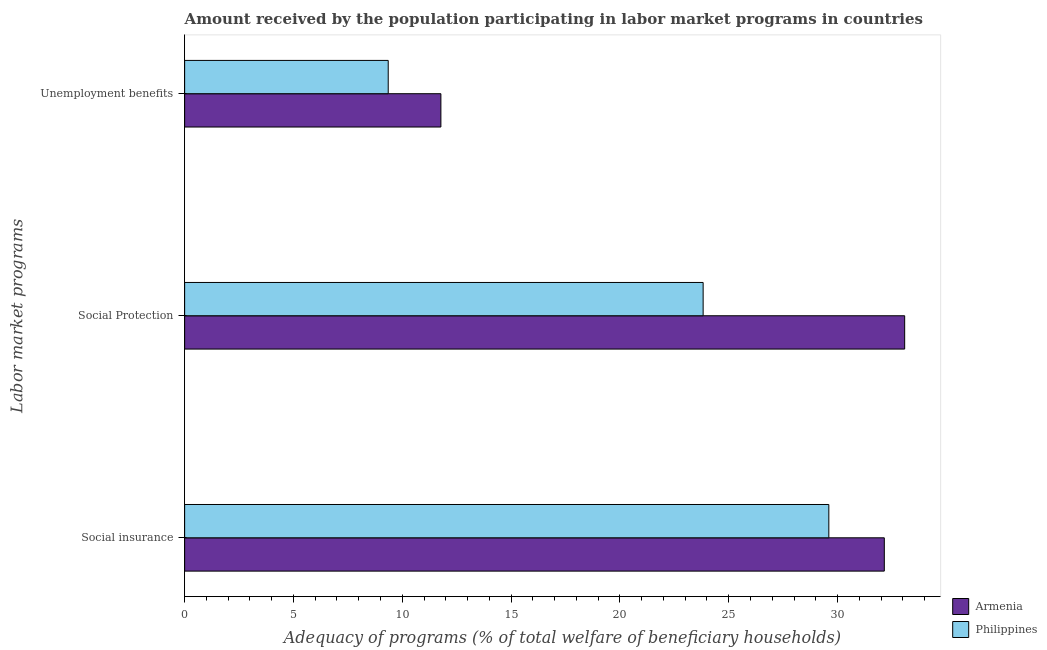Are the number of bars on each tick of the Y-axis equal?
Offer a very short reply. Yes. How many bars are there on the 3rd tick from the bottom?
Make the answer very short. 2. What is the label of the 2nd group of bars from the top?
Provide a short and direct response. Social Protection. What is the amount received by the population participating in social insurance programs in Philippines?
Ensure brevity in your answer.  29.6. Across all countries, what is the maximum amount received by the population participating in unemployment benefits programs?
Offer a terse response. 11.77. Across all countries, what is the minimum amount received by the population participating in unemployment benefits programs?
Ensure brevity in your answer.  9.35. In which country was the amount received by the population participating in social insurance programs maximum?
Your answer should be very brief. Armenia. In which country was the amount received by the population participating in social protection programs minimum?
Offer a terse response. Philippines. What is the total amount received by the population participating in unemployment benefits programs in the graph?
Your answer should be compact. 21.13. What is the difference between the amount received by the population participating in social protection programs in Philippines and that in Armenia?
Offer a terse response. -9.26. What is the difference between the amount received by the population participating in unemployment benefits programs in Armenia and the amount received by the population participating in social insurance programs in Philippines?
Offer a terse response. -17.83. What is the average amount received by the population participating in unemployment benefits programs per country?
Your response must be concise. 10.56. What is the difference between the amount received by the population participating in social insurance programs and amount received by the population participating in social protection programs in Philippines?
Keep it short and to the point. 5.78. In how many countries, is the amount received by the population participating in social protection programs greater than 23 %?
Give a very brief answer. 2. What is the ratio of the amount received by the population participating in unemployment benefits programs in Philippines to that in Armenia?
Keep it short and to the point. 0.79. Is the amount received by the population participating in social protection programs in Armenia less than that in Philippines?
Offer a terse response. No. Is the difference between the amount received by the population participating in social insurance programs in Philippines and Armenia greater than the difference between the amount received by the population participating in social protection programs in Philippines and Armenia?
Provide a succinct answer. Yes. What is the difference between the highest and the second highest amount received by the population participating in social protection programs?
Your answer should be very brief. 9.26. What is the difference between the highest and the lowest amount received by the population participating in unemployment benefits programs?
Your response must be concise. 2.42. In how many countries, is the amount received by the population participating in unemployment benefits programs greater than the average amount received by the population participating in unemployment benefits programs taken over all countries?
Your response must be concise. 1. Is the sum of the amount received by the population participating in unemployment benefits programs in Philippines and Armenia greater than the maximum amount received by the population participating in social protection programs across all countries?
Provide a short and direct response. No. What does the 2nd bar from the top in Unemployment benefits represents?
Your answer should be very brief. Armenia. Is it the case that in every country, the sum of the amount received by the population participating in social insurance programs and amount received by the population participating in social protection programs is greater than the amount received by the population participating in unemployment benefits programs?
Keep it short and to the point. Yes. How many bars are there?
Give a very brief answer. 6. Are the values on the major ticks of X-axis written in scientific E-notation?
Offer a terse response. No. Does the graph contain any zero values?
Offer a terse response. No. Does the graph contain grids?
Your answer should be very brief. No. How many legend labels are there?
Ensure brevity in your answer.  2. How are the legend labels stacked?
Offer a very short reply. Vertical. What is the title of the graph?
Offer a very short reply. Amount received by the population participating in labor market programs in countries. What is the label or title of the X-axis?
Provide a succinct answer. Adequacy of programs (% of total welfare of beneficiary households). What is the label or title of the Y-axis?
Ensure brevity in your answer.  Labor market programs. What is the Adequacy of programs (% of total welfare of beneficiary households) of Armenia in Social insurance?
Your answer should be very brief. 32.15. What is the Adequacy of programs (% of total welfare of beneficiary households) in Philippines in Social insurance?
Your answer should be very brief. 29.6. What is the Adequacy of programs (% of total welfare of beneficiary households) of Armenia in Social Protection?
Give a very brief answer. 33.08. What is the Adequacy of programs (% of total welfare of beneficiary households) in Philippines in Social Protection?
Keep it short and to the point. 23.82. What is the Adequacy of programs (% of total welfare of beneficiary households) in Armenia in Unemployment benefits?
Your answer should be compact. 11.77. What is the Adequacy of programs (% of total welfare of beneficiary households) in Philippines in Unemployment benefits?
Give a very brief answer. 9.35. Across all Labor market programs, what is the maximum Adequacy of programs (% of total welfare of beneficiary households) in Armenia?
Ensure brevity in your answer.  33.08. Across all Labor market programs, what is the maximum Adequacy of programs (% of total welfare of beneficiary households) in Philippines?
Your answer should be very brief. 29.6. Across all Labor market programs, what is the minimum Adequacy of programs (% of total welfare of beneficiary households) of Armenia?
Keep it short and to the point. 11.77. Across all Labor market programs, what is the minimum Adequacy of programs (% of total welfare of beneficiary households) of Philippines?
Give a very brief answer. 9.35. What is the total Adequacy of programs (% of total welfare of beneficiary households) in Armenia in the graph?
Your answer should be very brief. 77.01. What is the total Adequacy of programs (% of total welfare of beneficiary households) in Philippines in the graph?
Your response must be concise. 62.78. What is the difference between the Adequacy of programs (% of total welfare of beneficiary households) in Armenia in Social insurance and that in Social Protection?
Provide a short and direct response. -0.94. What is the difference between the Adequacy of programs (% of total welfare of beneficiary households) of Philippines in Social insurance and that in Social Protection?
Make the answer very short. 5.78. What is the difference between the Adequacy of programs (% of total welfare of beneficiary households) of Armenia in Social insurance and that in Unemployment benefits?
Your answer should be very brief. 20.37. What is the difference between the Adequacy of programs (% of total welfare of beneficiary households) in Philippines in Social insurance and that in Unemployment benefits?
Provide a short and direct response. 20.25. What is the difference between the Adequacy of programs (% of total welfare of beneficiary households) in Armenia in Social Protection and that in Unemployment benefits?
Your response must be concise. 21.31. What is the difference between the Adequacy of programs (% of total welfare of beneficiary households) in Philippines in Social Protection and that in Unemployment benefits?
Make the answer very short. 14.47. What is the difference between the Adequacy of programs (% of total welfare of beneficiary households) in Armenia in Social insurance and the Adequacy of programs (% of total welfare of beneficiary households) in Philippines in Social Protection?
Offer a terse response. 8.32. What is the difference between the Adequacy of programs (% of total welfare of beneficiary households) in Armenia in Social insurance and the Adequacy of programs (% of total welfare of beneficiary households) in Philippines in Unemployment benefits?
Make the answer very short. 22.79. What is the difference between the Adequacy of programs (% of total welfare of beneficiary households) of Armenia in Social Protection and the Adequacy of programs (% of total welfare of beneficiary households) of Philippines in Unemployment benefits?
Give a very brief answer. 23.73. What is the average Adequacy of programs (% of total welfare of beneficiary households) in Armenia per Labor market programs?
Your answer should be very brief. 25.67. What is the average Adequacy of programs (% of total welfare of beneficiary households) in Philippines per Labor market programs?
Give a very brief answer. 20.93. What is the difference between the Adequacy of programs (% of total welfare of beneficiary households) in Armenia and Adequacy of programs (% of total welfare of beneficiary households) in Philippines in Social insurance?
Give a very brief answer. 2.55. What is the difference between the Adequacy of programs (% of total welfare of beneficiary households) in Armenia and Adequacy of programs (% of total welfare of beneficiary households) in Philippines in Social Protection?
Keep it short and to the point. 9.26. What is the difference between the Adequacy of programs (% of total welfare of beneficiary households) of Armenia and Adequacy of programs (% of total welfare of beneficiary households) of Philippines in Unemployment benefits?
Your answer should be very brief. 2.42. What is the ratio of the Adequacy of programs (% of total welfare of beneficiary households) in Armenia in Social insurance to that in Social Protection?
Keep it short and to the point. 0.97. What is the ratio of the Adequacy of programs (% of total welfare of beneficiary households) of Philippines in Social insurance to that in Social Protection?
Keep it short and to the point. 1.24. What is the ratio of the Adequacy of programs (% of total welfare of beneficiary households) of Armenia in Social insurance to that in Unemployment benefits?
Your answer should be compact. 2.73. What is the ratio of the Adequacy of programs (% of total welfare of beneficiary households) of Philippines in Social insurance to that in Unemployment benefits?
Your answer should be very brief. 3.16. What is the ratio of the Adequacy of programs (% of total welfare of beneficiary households) in Armenia in Social Protection to that in Unemployment benefits?
Ensure brevity in your answer.  2.81. What is the ratio of the Adequacy of programs (% of total welfare of beneficiary households) in Philippines in Social Protection to that in Unemployment benefits?
Your answer should be very brief. 2.55. What is the difference between the highest and the second highest Adequacy of programs (% of total welfare of beneficiary households) of Armenia?
Make the answer very short. 0.94. What is the difference between the highest and the second highest Adequacy of programs (% of total welfare of beneficiary households) in Philippines?
Your answer should be very brief. 5.78. What is the difference between the highest and the lowest Adequacy of programs (% of total welfare of beneficiary households) in Armenia?
Give a very brief answer. 21.31. What is the difference between the highest and the lowest Adequacy of programs (% of total welfare of beneficiary households) in Philippines?
Offer a very short reply. 20.25. 